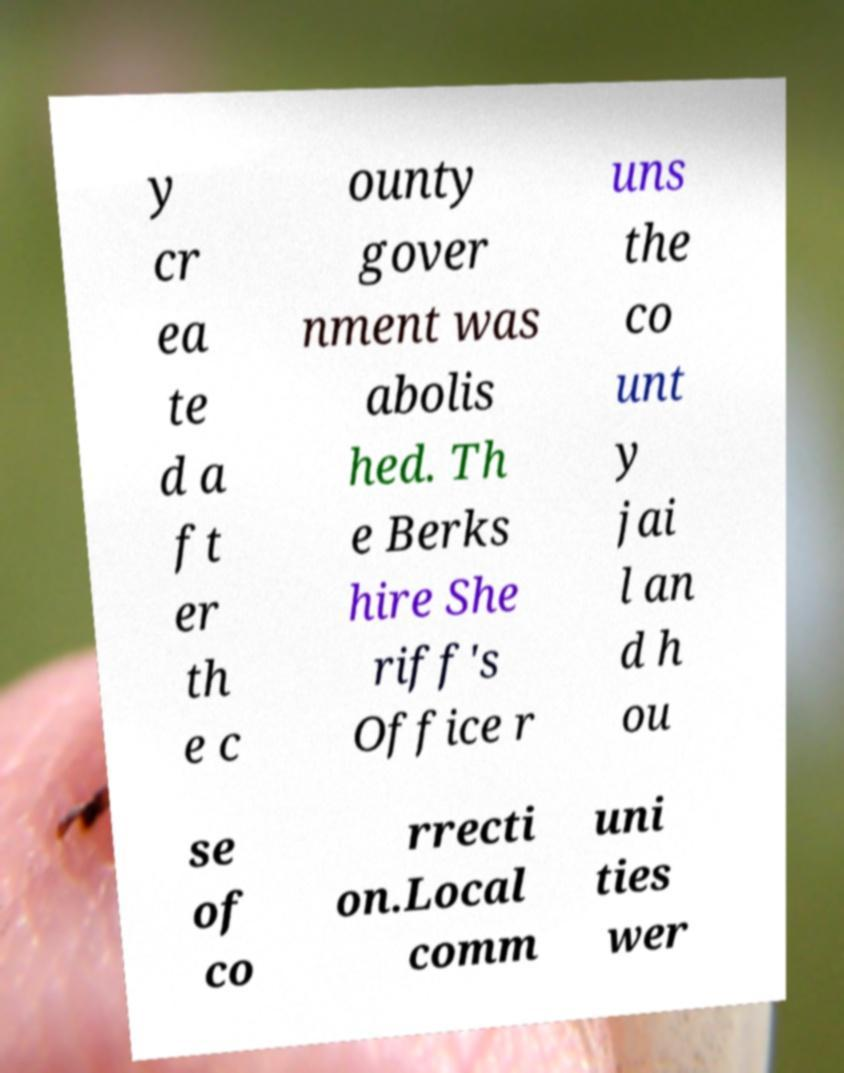There's text embedded in this image that I need extracted. Can you transcribe it verbatim? y cr ea te d a ft er th e c ounty gover nment was abolis hed. Th e Berks hire She riff's Office r uns the co unt y jai l an d h ou se of co rrecti on.Local comm uni ties wer 